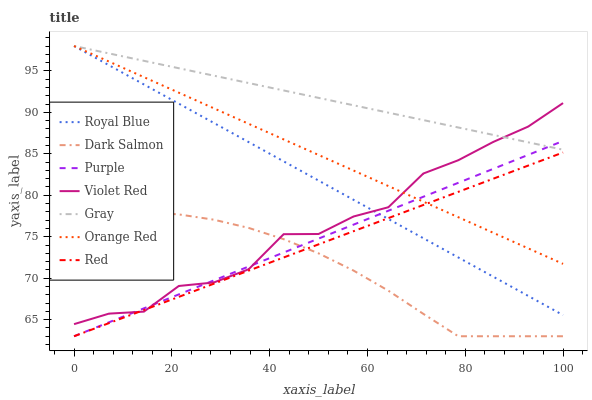Does Dark Salmon have the minimum area under the curve?
Answer yes or no. Yes. Does Gray have the maximum area under the curve?
Answer yes or no. Yes. Does Violet Red have the minimum area under the curve?
Answer yes or no. No. Does Violet Red have the maximum area under the curve?
Answer yes or no. No. Is Purple the smoothest?
Answer yes or no. Yes. Is Violet Red the roughest?
Answer yes or no. Yes. Is Violet Red the smoothest?
Answer yes or no. No. Is Purple the roughest?
Answer yes or no. No. Does Purple have the lowest value?
Answer yes or no. Yes. Does Violet Red have the lowest value?
Answer yes or no. No. Does Orange Red have the highest value?
Answer yes or no. Yes. Does Violet Red have the highest value?
Answer yes or no. No. Is Dark Salmon less than Royal Blue?
Answer yes or no. Yes. Is Gray greater than Red?
Answer yes or no. Yes. Does Orange Red intersect Royal Blue?
Answer yes or no. Yes. Is Orange Red less than Royal Blue?
Answer yes or no. No. Is Orange Red greater than Royal Blue?
Answer yes or no. No. Does Dark Salmon intersect Royal Blue?
Answer yes or no. No. 